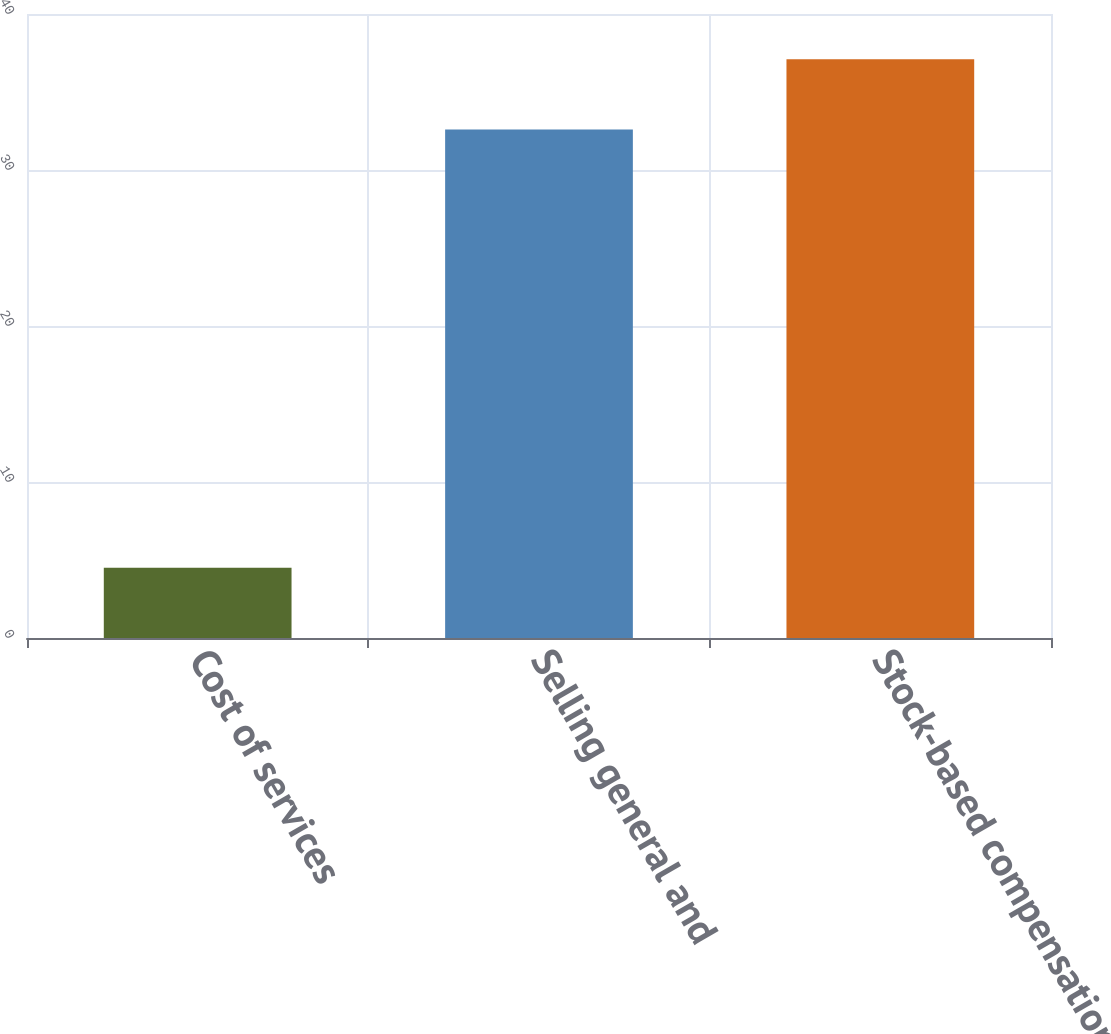Convert chart to OTSL. <chart><loc_0><loc_0><loc_500><loc_500><bar_chart><fcel>Cost of services<fcel>Selling general and<fcel>Stock-based compensation<nl><fcel>4.5<fcel>32.6<fcel>37.1<nl></chart> 